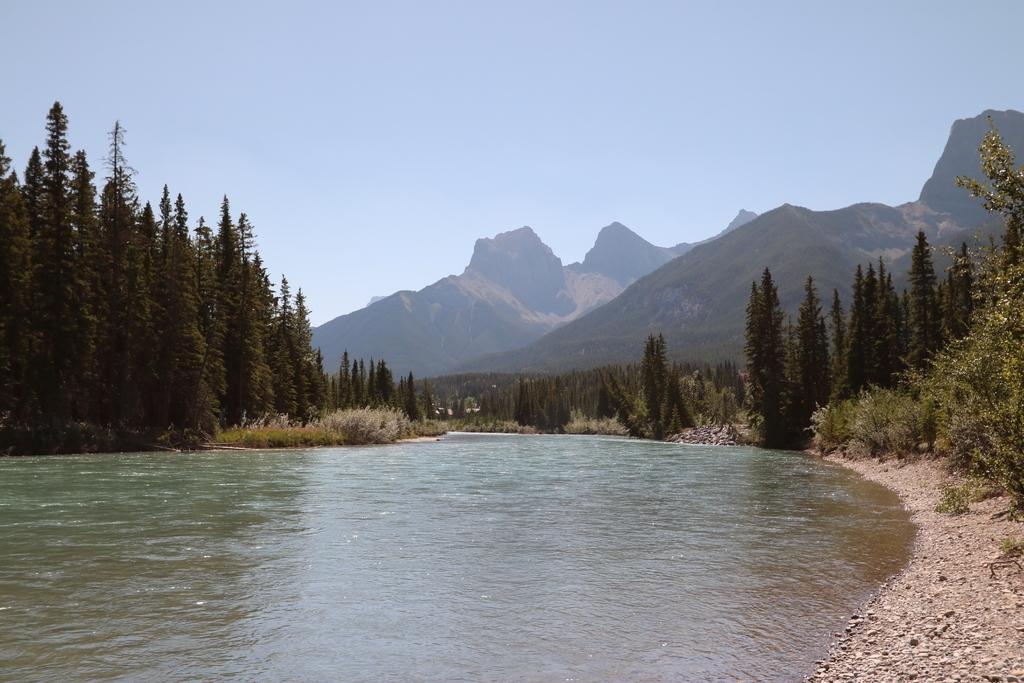What is the primary element visible in the image? There is water in the image. What type of natural features can be seen in the image? There are trees and hills visible in the image. What is visible in the background of the image? The sky is visible in the background of the image. How many whips are being used to control the trains in the image? There are no whips or trains present in the image. 